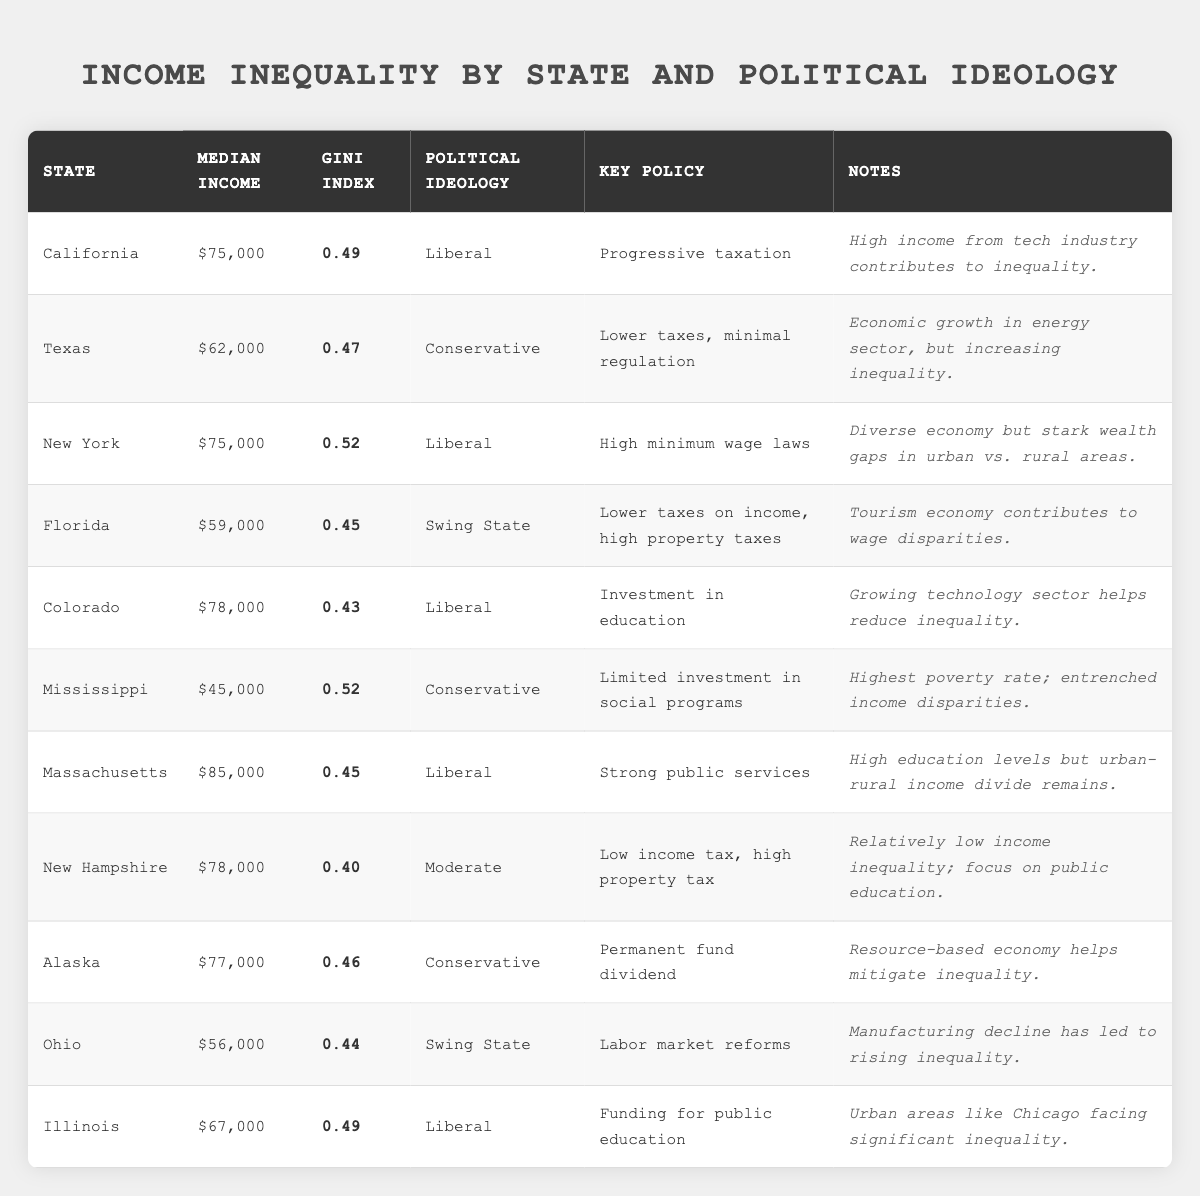What is the median income in California? The table lists California with a median income of $75,000 for the state under the respective column.
Answer: $75,000 Which state has the highest Gini index? Looking through the Gini index values, New York and Mississippi both have a Gini index of 0.52, which is the highest among all the listed states.
Answer: New York and Mississippi What is the average median income of states with a Liberal political ideology? The median incomes for the Liberal states (California, New York, Colorado, Massachusetts, and Illinois) are $75,000, $75,000, $78,000, $85,000, and $67,000, respectively. Summing these gives $75,000 + $75,000 + $78,000 + $85,000 + $67,000 = $380,000. There are 5 states, so the average is $380,000 / 5 = $76,000.
Answer: $76,000 Is the Gini index in Florida lower than that in Texas? Florida has a Gini index of 0.45 while Texas's Gini index is 0.47. Since 0.45 is less than 0.47, the statement is true.
Answer: Yes Which state with a Conservative ideology has the lowest median income? Comparing the median incomes of Conservative states, Texas has $62,000 and Mississippi has $45,000. Since $45,000 is lower than $62,000, Mississippi has the lowest median income among Conservative states.
Answer: Mississippi What is the Gini index for New Hampshire? The table lists New Hampshire with a Gini index of 0.40 under the respective column.
Answer: 0.40 Which state has a higher median income: Illinois or Florida? Illinois has a median income of $67,000, while Florida has a median income of $59,000. Since $67,000 is greater than $59,000, Illinois has a higher median income.
Answer: Illinois Do any states with a Swing State political ideology have a Gini index greater than 0.45? The Gini indices for Swing States Florida and Ohio are 0.45 and 0.44, respectively. Since both values are not above 0.45, the answer is no.
Answer: No How many states have a Gini index below 0.45? By examining the Gini index values, only Colorado with 0.43 and New Hampshire with 0.40 have values below 0.45, totaling 2 states.
Answer: 2 